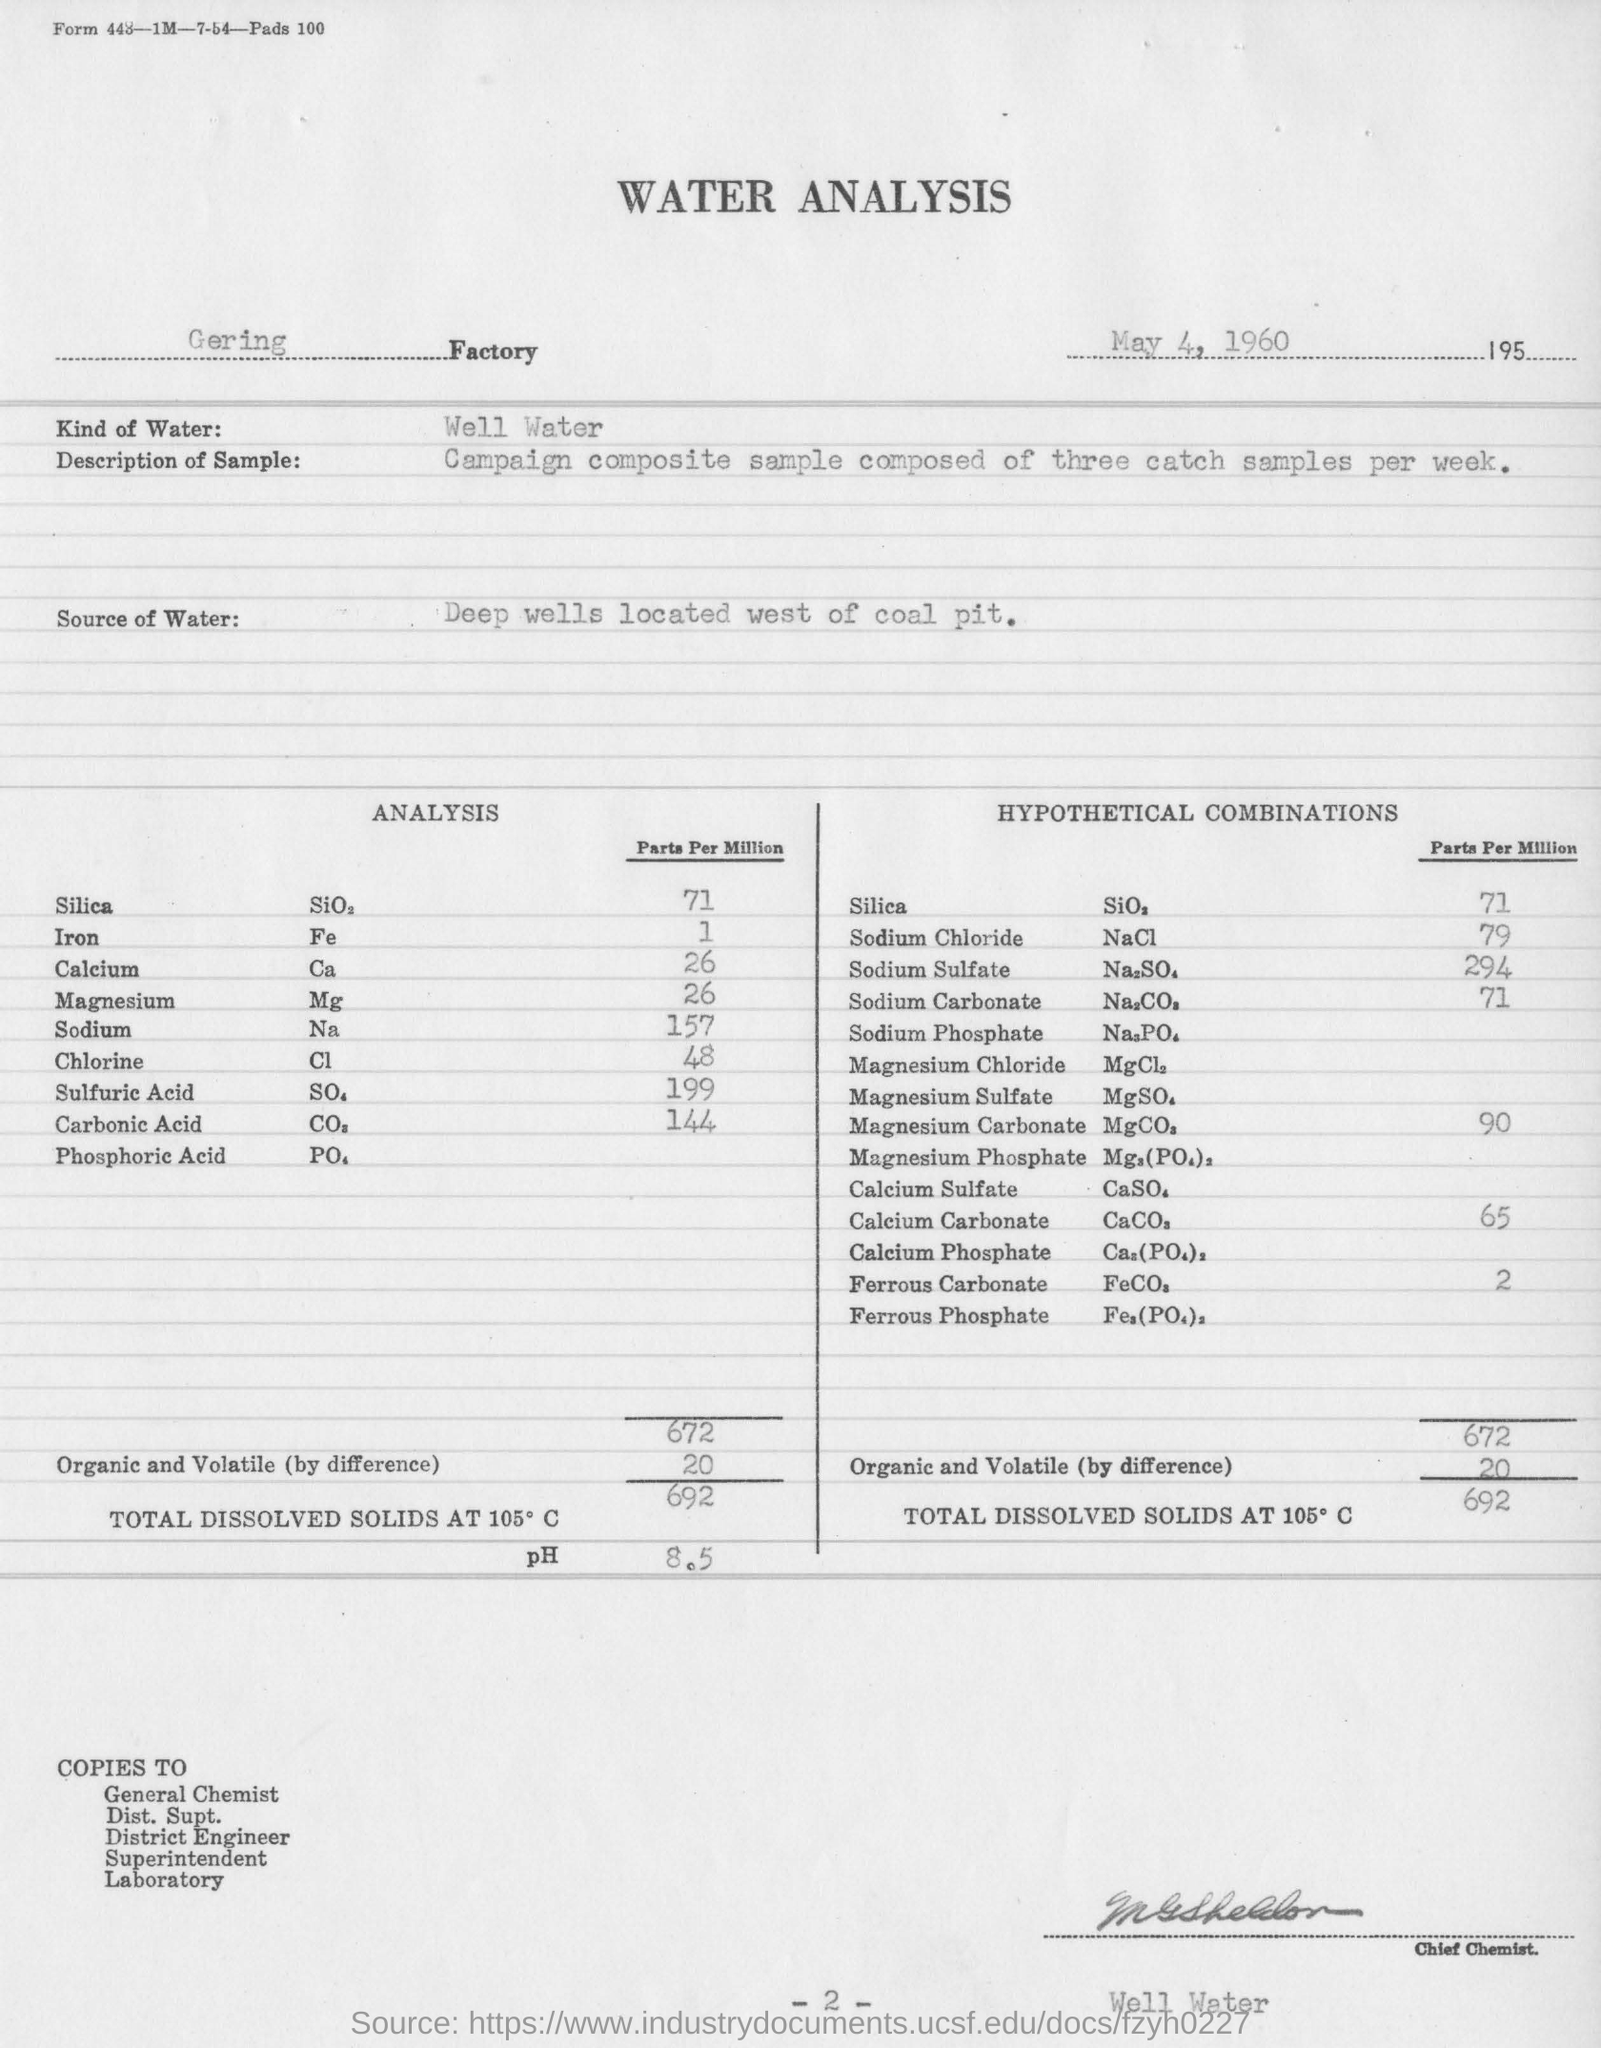What is the date mentioned in this report?
Provide a succinct answer. May 4, 1960. What kind of water is it?
Keep it short and to the point. Well water. What is the source of water?
Provide a succinct answer. Deep wells located west of coal pit. 